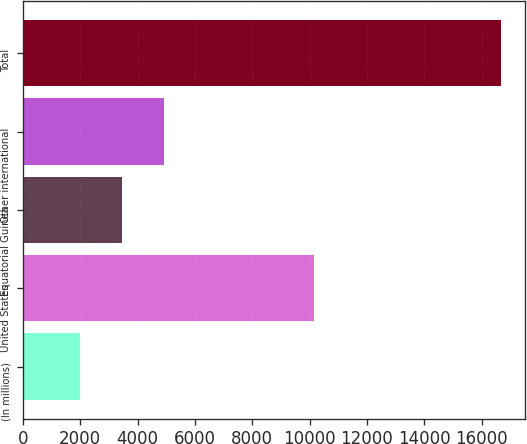Convert chart. <chart><loc_0><loc_0><loc_500><loc_500><bar_chart><fcel>(In millions)<fcel>United States<fcel>Equatorial Guinea<fcel>Other international<fcel>Total<nl><fcel>2005<fcel>10143<fcel>3471.6<fcel>4938.2<fcel>16671<nl></chart> 